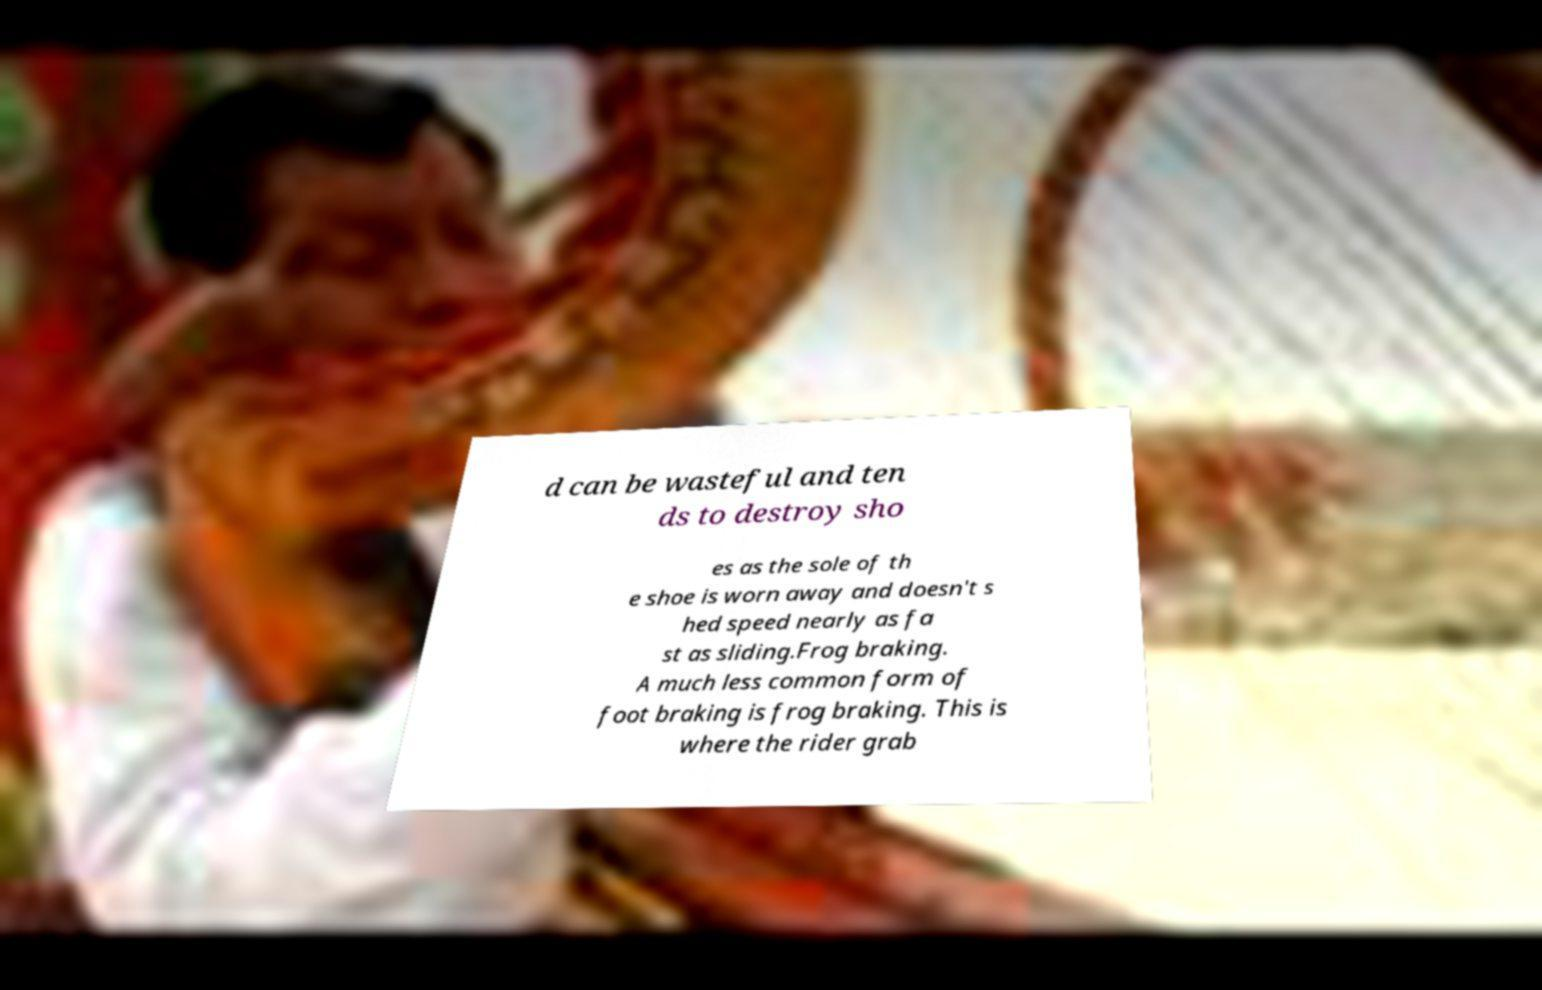I need the written content from this picture converted into text. Can you do that? d can be wasteful and ten ds to destroy sho es as the sole of th e shoe is worn away and doesn't s hed speed nearly as fa st as sliding.Frog braking. A much less common form of foot braking is frog braking. This is where the rider grab 